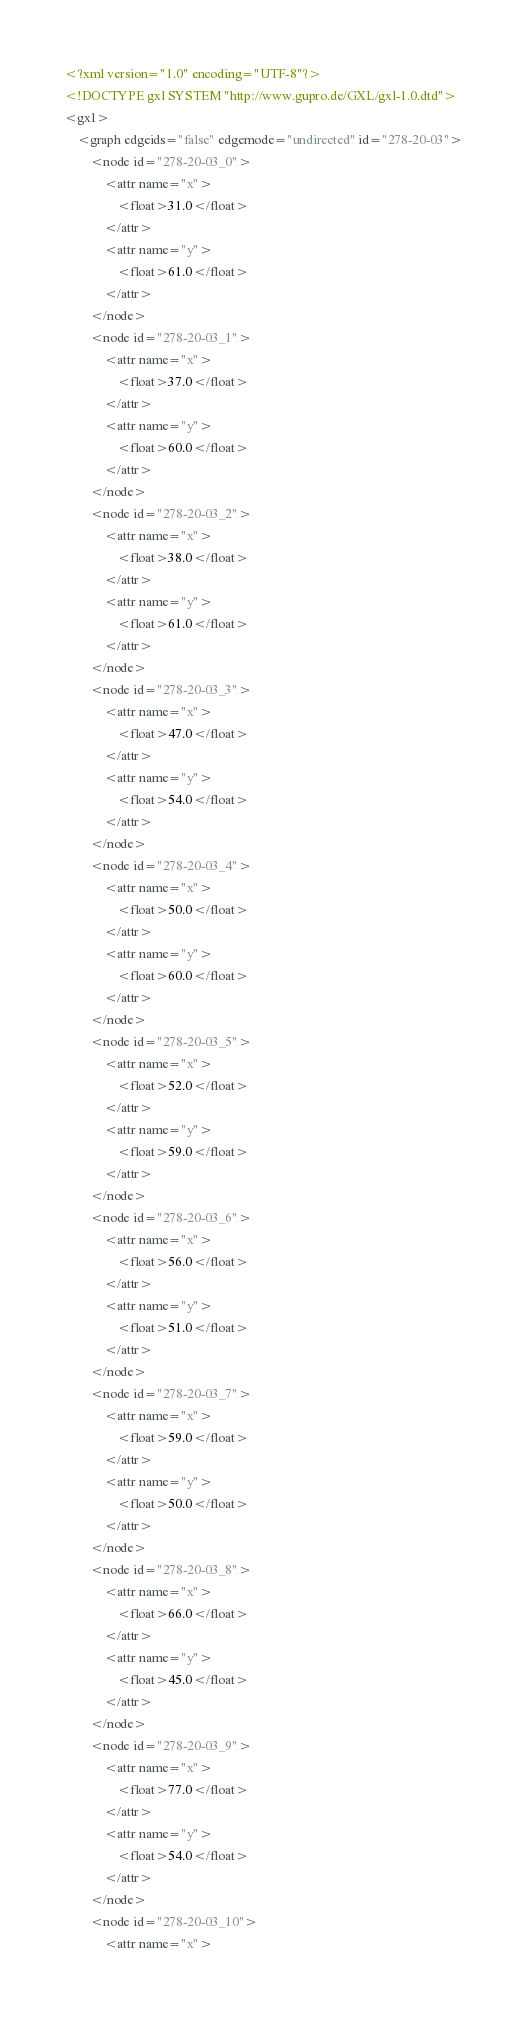Convert code to text. <code><loc_0><loc_0><loc_500><loc_500><_XML_><?xml version="1.0" encoding="UTF-8"?>
<!DOCTYPE gxl SYSTEM "http://www.gupro.de/GXL/gxl-1.0.dtd">
<gxl>
	<graph edgeids="false" edgemode="undirected" id="278-20-03">
		<node id="278-20-03_0">
			<attr name="x">
				<float>31.0</float>
			</attr>
			<attr name="y">
				<float>61.0</float>
			</attr>
		</node>
		<node id="278-20-03_1">
			<attr name="x">
				<float>37.0</float>
			</attr>
			<attr name="y">
				<float>60.0</float>
			</attr>
		</node>
		<node id="278-20-03_2">
			<attr name="x">
				<float>38.0</float>
			</attr>
			<attr name="y">
				<float>61.0</float>
			</attr>
		</node>
		<node id="278-20-03_3">
			<attr name="x">
				<float>47.0</float>
			</attr>
			<attr name="y">
				<float>54.0</float>
			</attr>
		</node>
		<node id="278-20-03_4">
			<attr name="x">
				<float>50.0</float>
			</attr>
			<attr name="y">
				<float>60.0</float>
			</attr>
		</node>
		<node id="278-20-03_5">
			<attr name="x">
				<float>52.0</float>
			</attr>
			<attr name="y">
				<float>59.0</float>
			</attr>
		</node>
		<node id="278-20-03_6">
			<attr name="x">
				<float>56.0</float>
			</attr>
			<attr name="y">
				<float>51.0</float>
			</attr>
		</node>
		<node id="278-20-03_7">
			<attr name="x">
				<float>59.0</float>
			</attr>
			<attr name="y">
				<float>50.0</float>
			</attr>
		</node>
		<node id="278-20-03_8">
			<attr name="x">
				<float>66.0</float>
			</attr>
			<attr name="y">
				<float>45.0</float>
			</attr>
		</node>
		<node id="278-20-03_9">
			<attr name="x">
				<float>77.0</float>
			</attr>
			<attr name="y">
				<float>54.0</float>
			</attr>
		</node>
		<node id="278-20-03_10">
			<attr name="x"></code> 